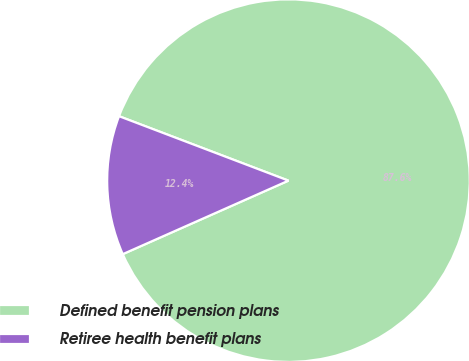Convert chart. <chart><loc_0><loc_0><loc_500><loc_500><pie_chart><fcel>Defined benefit pension plans<fcel>Retiree health benefit plans<nl><fcel>87.57%<fcel>12.43%<nl></chart> 